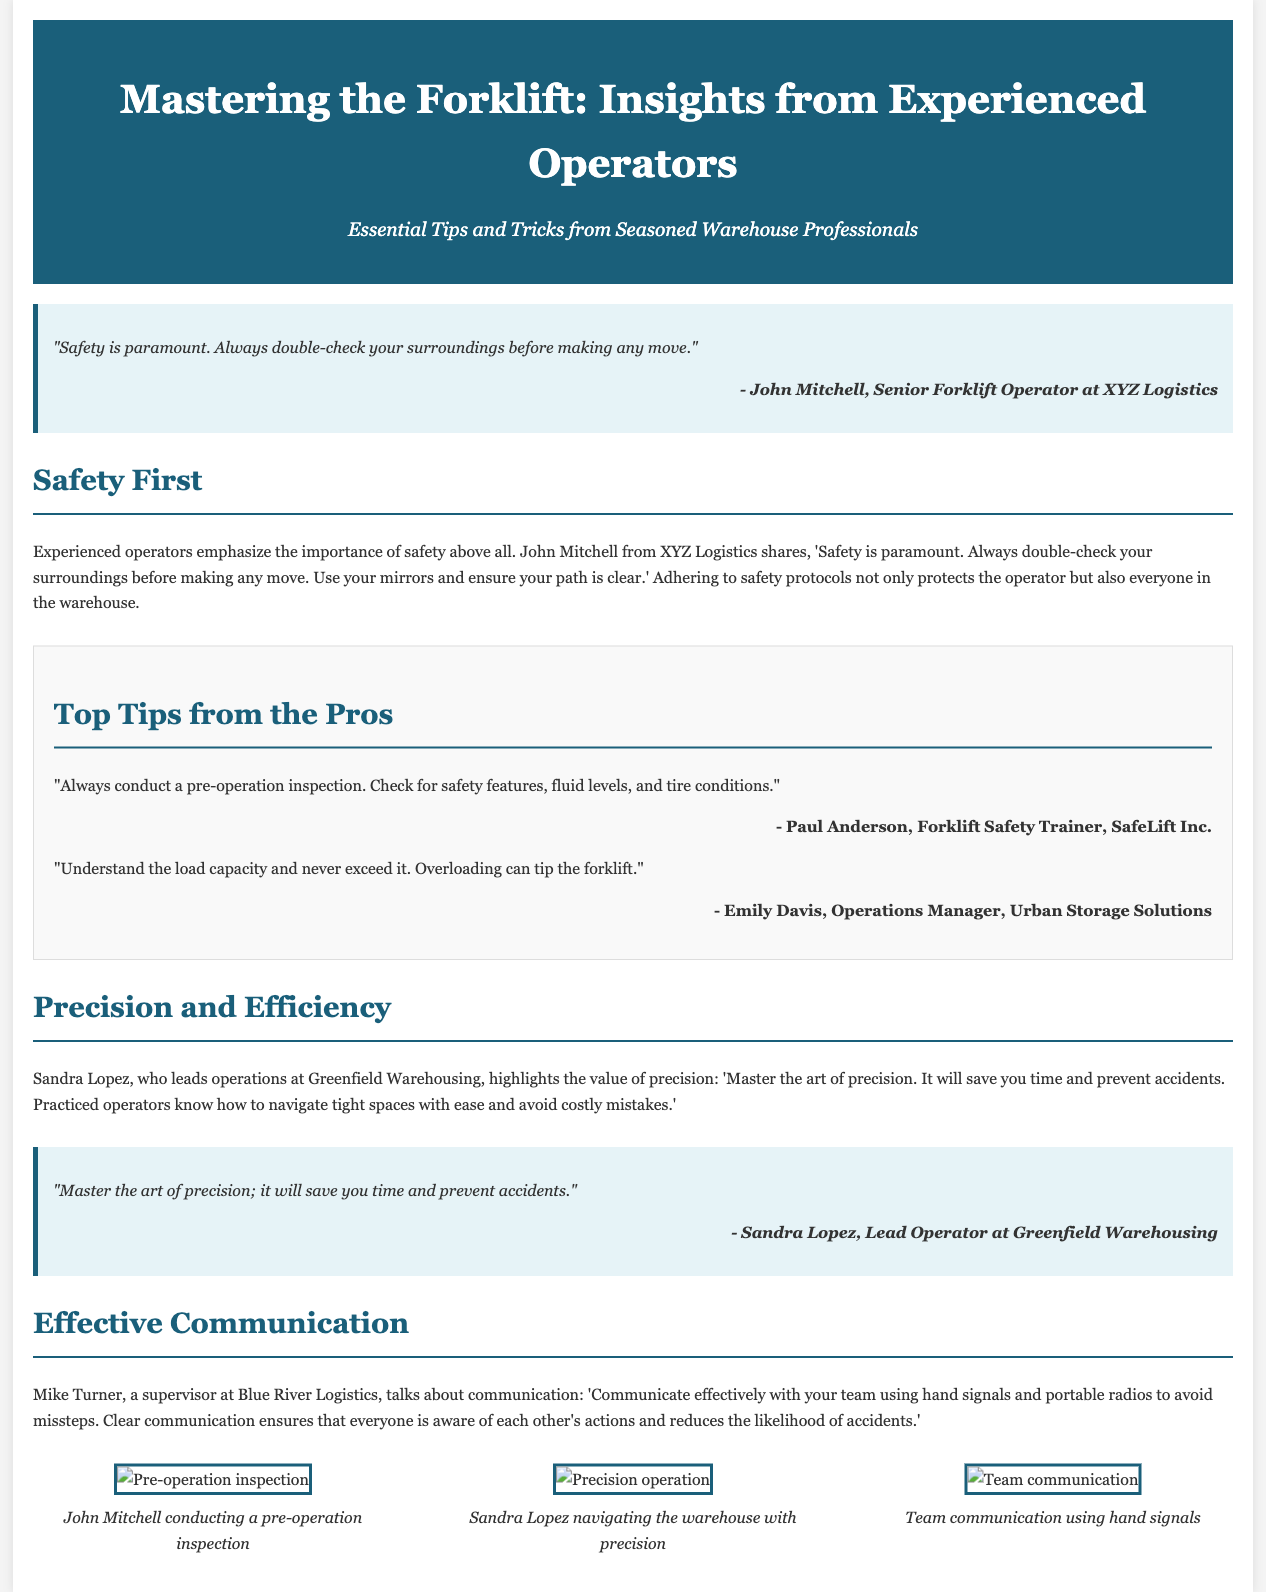What is the title of the article? The title is stated in the header of the document.
Answer: Mastering the Forklift: Insights from Experienced Operators Who is quoted saying "Safety is paramount."? The quote is attributed to John Mitchell in the document.
Answer: John Mitchell What are operators encouraged to check during a pre-operation inspection? The tips mentioned in the document include safety features, fluid levels, and tire conditions.
Answer: Safety features, fluid levels, and tire conditions What is the main value emphasized by Sandra Lopez? The content emphasizes the importance of precision in operations, as discussed by Sandra Lopez.
Answer: Precision Which communication method is suggested by Mike Turner for effective teamwork? Mike Turner mentions the use of hand signals and portable radios for communication.
Answer: Hand signals and portable radios How many photos are included in the photo gallery? The document lists three photo sections in the gallery.
Answer: Three 